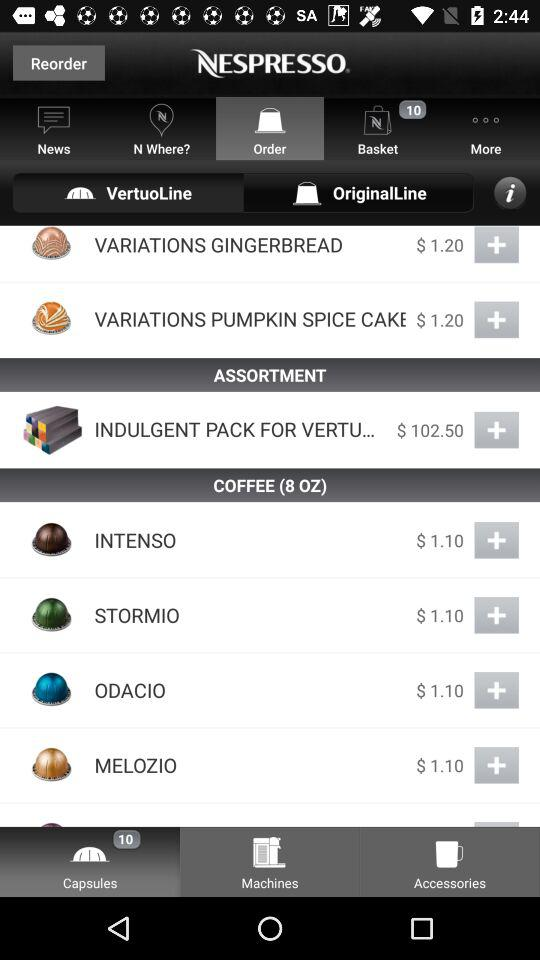What is the number of items in the basket? There are 10 items in the basket. 